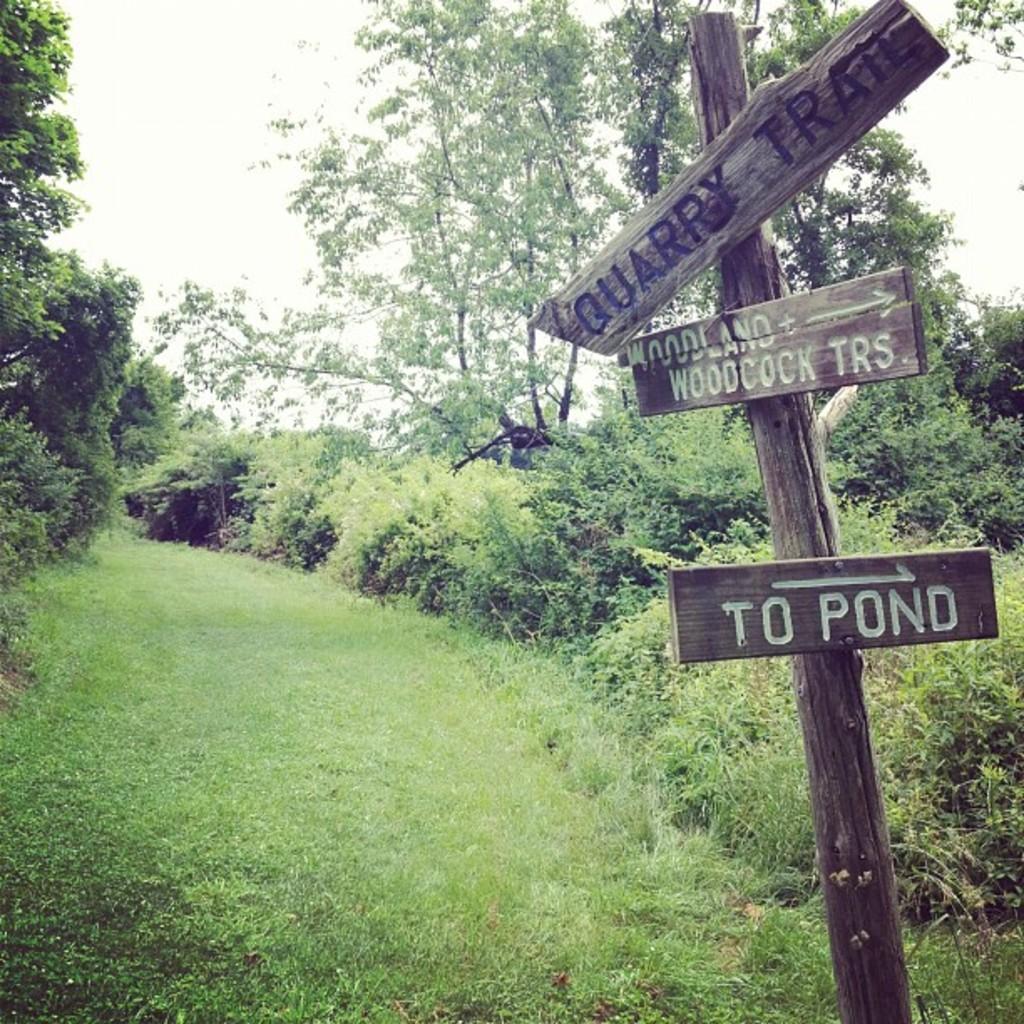Could you give a brief overview of what you see in this image? In this image I can see a wooden log to which I can see few boards attached, some grass and few plants. In the background I can see few trees and the sky. 